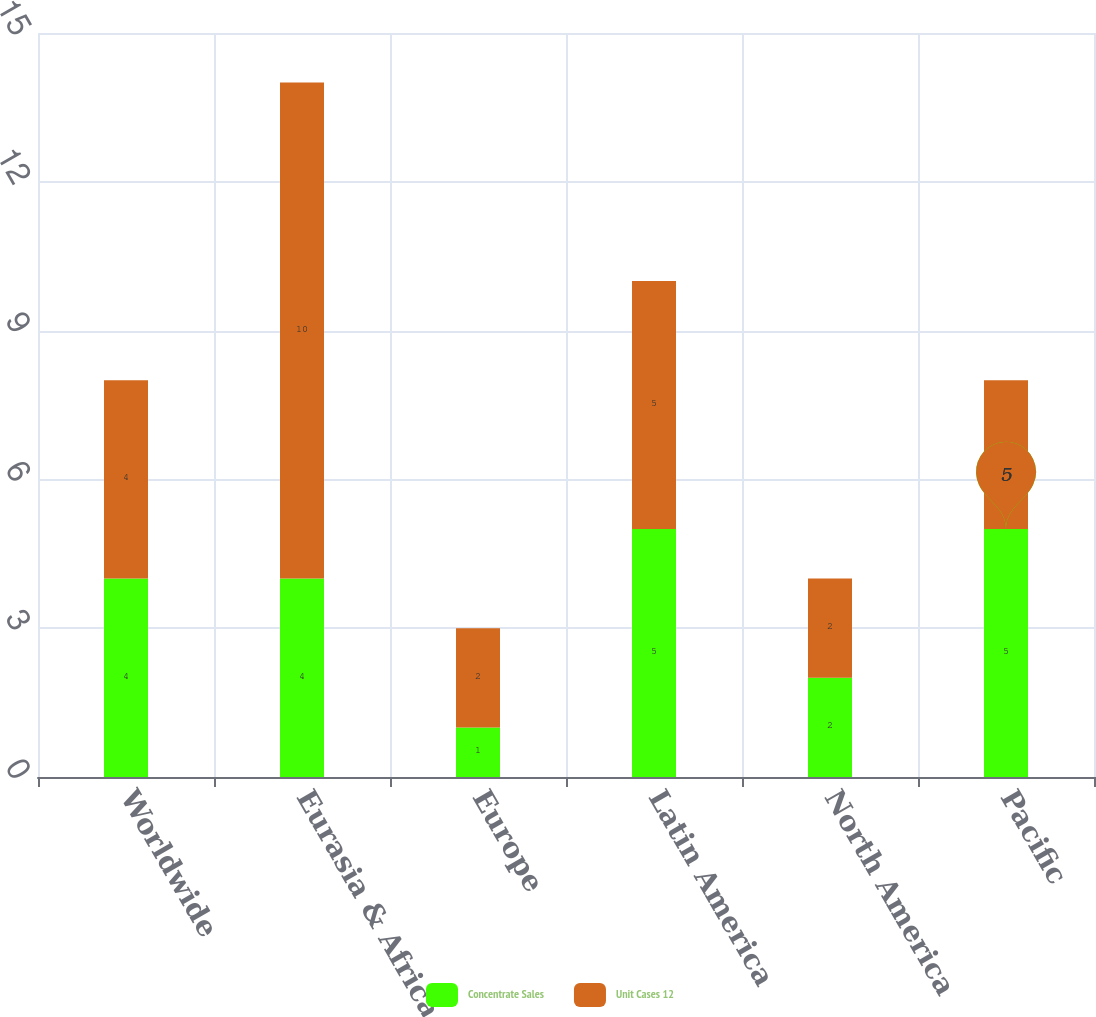<chart> <loc_0><loc_0><loc_500><loc_500><stacked_bar_chart><ecel><fcel>Worldwide<fcel>Eurasia & Africa<fcel>Europe<fcel>Latin America<fcel>North America<fcel>Pacific<nl><fcel>Concentrate Sales<fcel>4<fcel>4<fcel>1<fcel>5<fcel>2<fcel>5<nl><fcel>Unit Cases 12<fcel>4<fcel>10<fcel>2<fcel>5<fcel>2<fcel>3<nl></chart> 